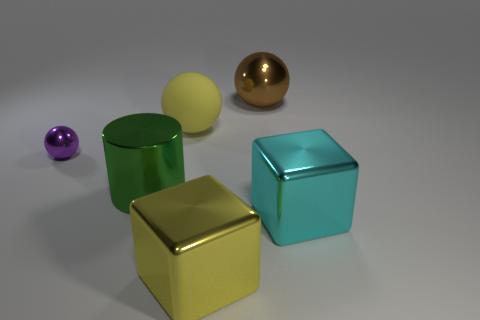There is a sphere left of the green cylinder; what material is it?
Make the answer very short. Metal. What number of shiny objects are big things or purple spheres?
Give a very brief answer. 5. What is the color of the metallic ball that is in front of the large ball to the right of the yellow metal object?
Make the answer very short. Purple. Are the big brown thing and the yellow thing that is in front of the large cylinder made of the same material?
Ensure brevity in your answer.  Yes. There is a shiny block left of the shiny object that is to the right of the metal sphere that is behind the tiny purple object; what color is it?
Give a very brief answer. Yellow. Is there anything else that is the same shape as the tiny purple thing?
Keep it short and to the point. Yes. Are there more big brown objects than matte blocks?
Give a very brief answer. Yes. How many objects are in front of the tiny purple metallic ball and behind the purple shiny sphere?
Your answer should be very brief. 0. What number of large shiny blocks are left of the shiny sphere on the right side of the large green shiny cylinder?
Offer a very short reply. 1. Does the yellow thing that is behind the yellow shiny cube have the same size as the shiny thing in front of the large cyan shiny block?
Provide a succinct answer. Yes. 